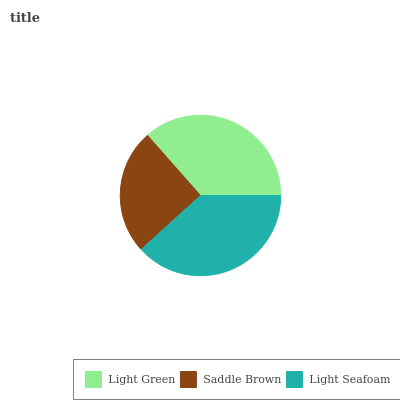Is Saddle Brown the minimum?
Answer yes or no. Yes. Is Light Seafoam the maximum?
Answer yes or no. Yes. Is Light Seafoam the minimum?
Answer yes or no. No. Is Saddle Brown the maximum?
Answer yes or no. No. Is Light Seafoam greater than Saddle Brown?
Answer yes or no. Yes. Is Saddle Brown less than Light Seafoam?
Answer yes or no. Yes. Is Saddle Brown greater than Light Seafoam?
Answer yes or no. No. Is Light Seafoam less than Saddle Brown?
Answer yes or no. No. Is Light Green the high median?
Answer yes or no. Yes. Is Light Green the low median?
Answer yes or no. Yes. Is Saddle Brown the high median?
Answer yes or no. No. Is Saddle Brown the low median?
Answer yes or no. No. 